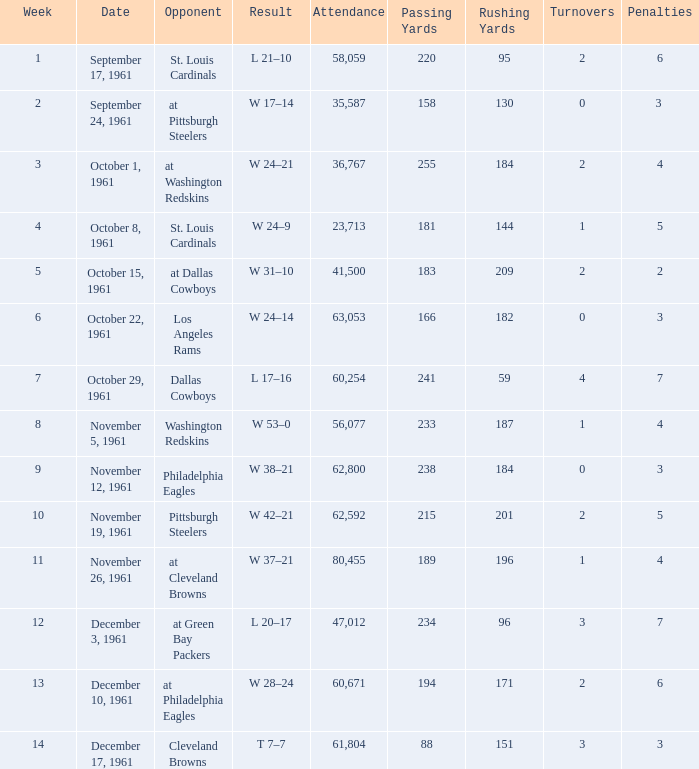Which Attendance has a Date of november 19, 1961? 62592.0. 